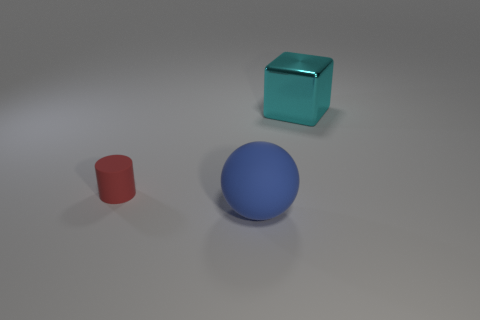Add 1 tiny red matte cylinders. How many objects exist? 4 Subtract all blocks. How many objects are left? 2 Add 1 tiny red cylinders. How many tiny red cylinders exist? 2 Subtract 0 green cubes. How many objects are left? 3 Subtract all small metal objects. Subtract all matte objects. How many objects are left? 1 Add 3 large blue things. How many large blue things are left? 4 